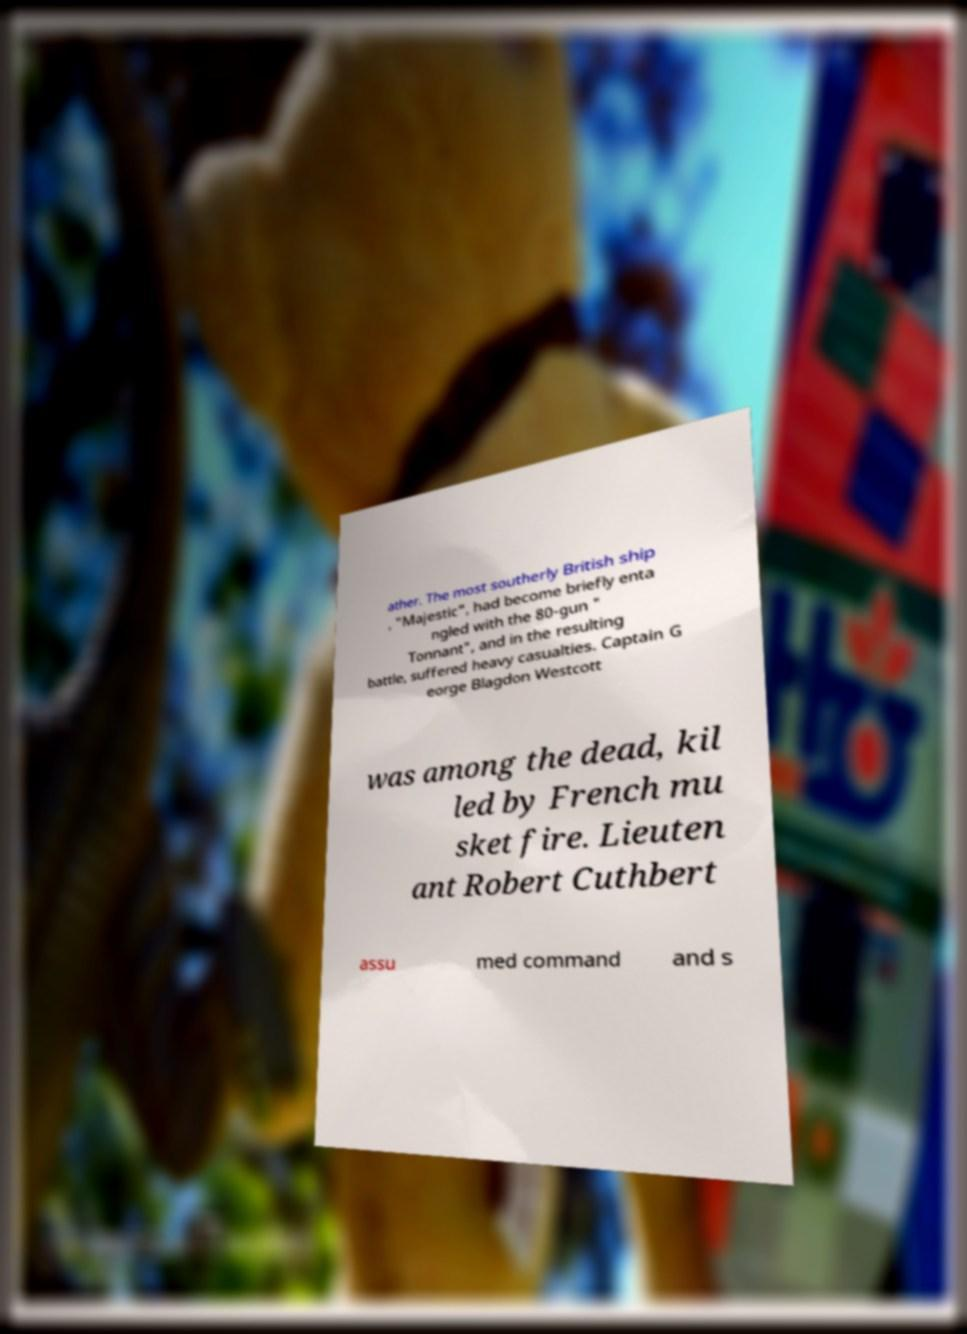There's text embedded in this image that I need extracted. Can you transcribe it verbatim? ather. The most southerly British ship , "Majestic", had become briefly enta ngled with the 80-gun " Tonnant", and in the resulting battle, suffered heavy casualties. Captain G eorge Blagdon Westcott was among the dead, kil led by French mu sket fire. Lieuten ant Robert Cuthbert assu med command and s 